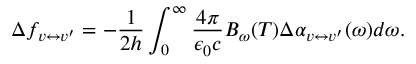Convert formula to latex. <formula><loc_0><loc_0><loc_500><loc_500>\Delta f _ { v \leftrightarrow v ^ { \prime } } = - \frac { 1 } { 2 h } \int _ { 0 } ^ { \infty } \frac { 4 \pi } { \epsilon _ { 0 } c } B _ { \omega } ( T ) \Delta \alpha _ { v \leftrightarrow v ^ { \prime } } ( \omega ) d \omega .</formula> 